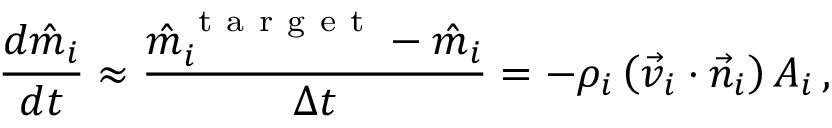<formula> <loc_0><loc_0><loc_500><loc_500>\frac { d \hat { m } _ { i } } { d t } \approx \frac { \hat { m } _ { i } ^ { t a r g e t } - \hat { m } _ { i } } { \Delta t } = - \rho _ { i } \left ( \vec { v } _ { i } \cdot \vec { n } _ { i } \right ) A _ { i } \, ,</formula> 